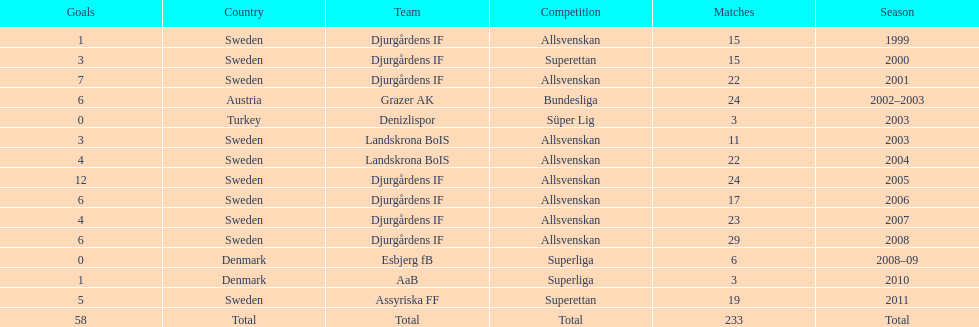How many matches did jones kusi-asare play in in his first season? 15. 